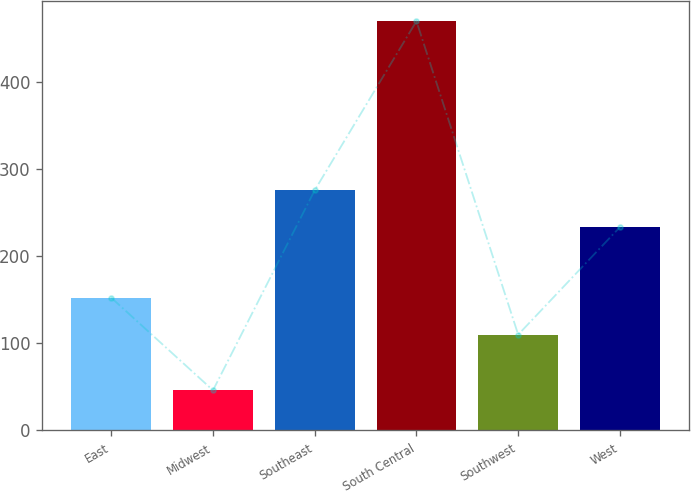Convert chart to OTSL. <chart><loc_0><loc_0><loc_500><loc_500><bar_chart><fcel>East<fcel>Midwest<fcel>Southeast<fcel>South Central<fcel>Southwest<fcel>West<nl><fcel>152.34<fcel>45.9<fcel>275.94<fcel>470.3<fcel>109.9<fcel>233.5<nl></chart> 